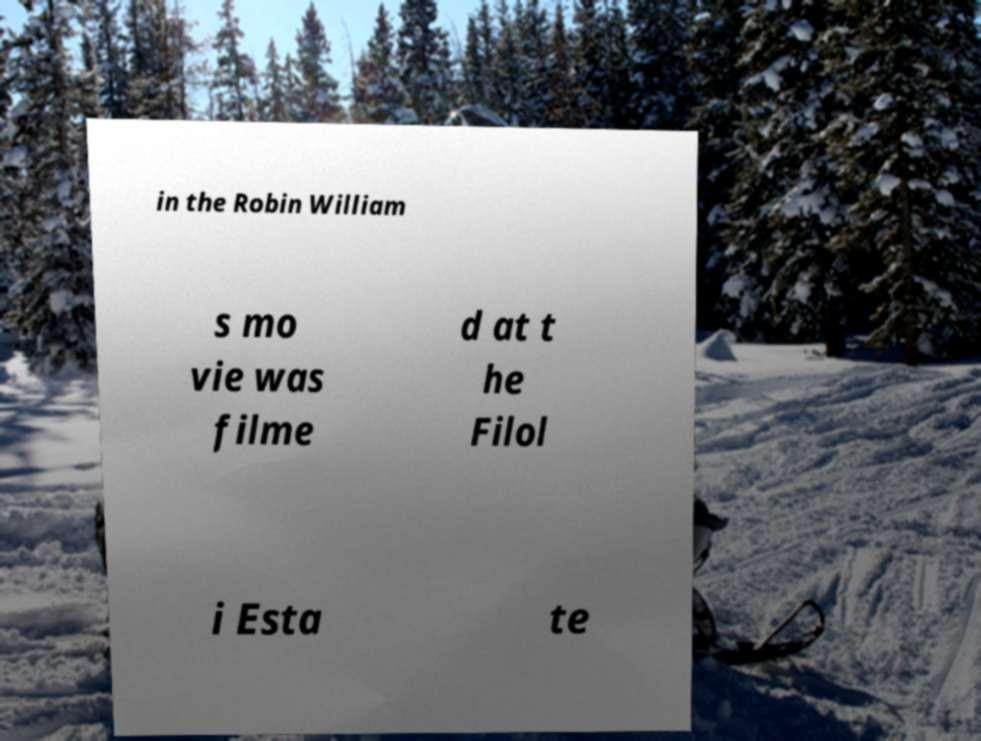Can you accurately transcribe the text from the provided image for me? in the Robin William s mo vie was filme d at t he Filol i Esta te 